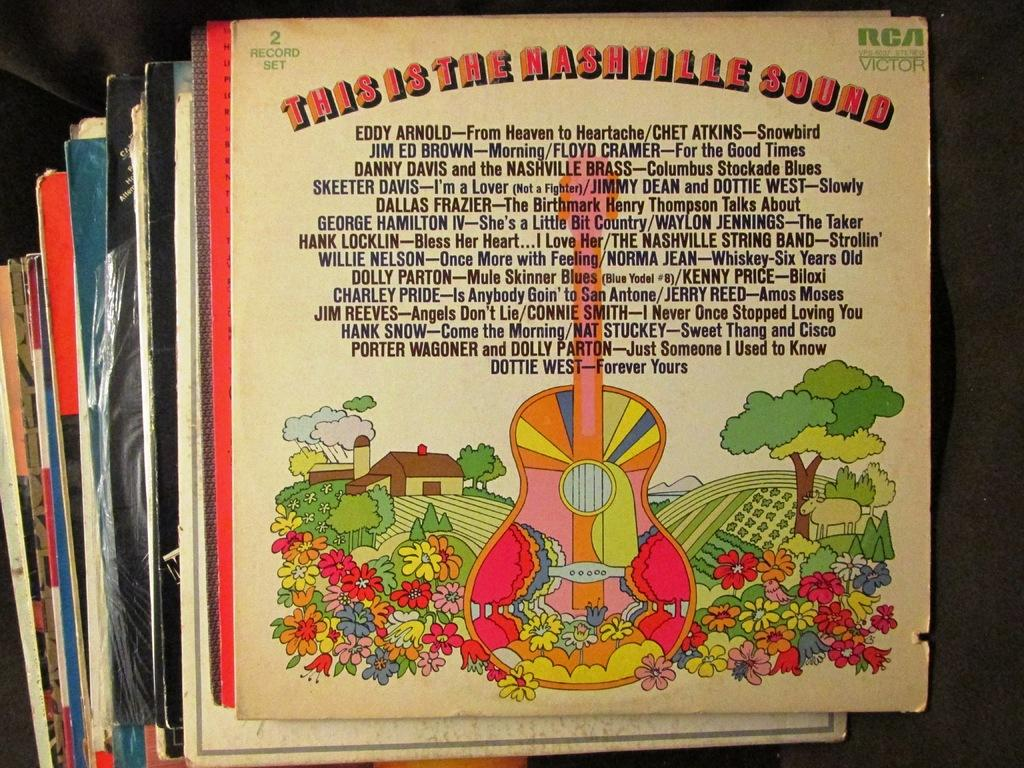<image>
Give a short and clear explanation of the subsequent image. A vinyl sleeve labeled This is the Nashville Sound 